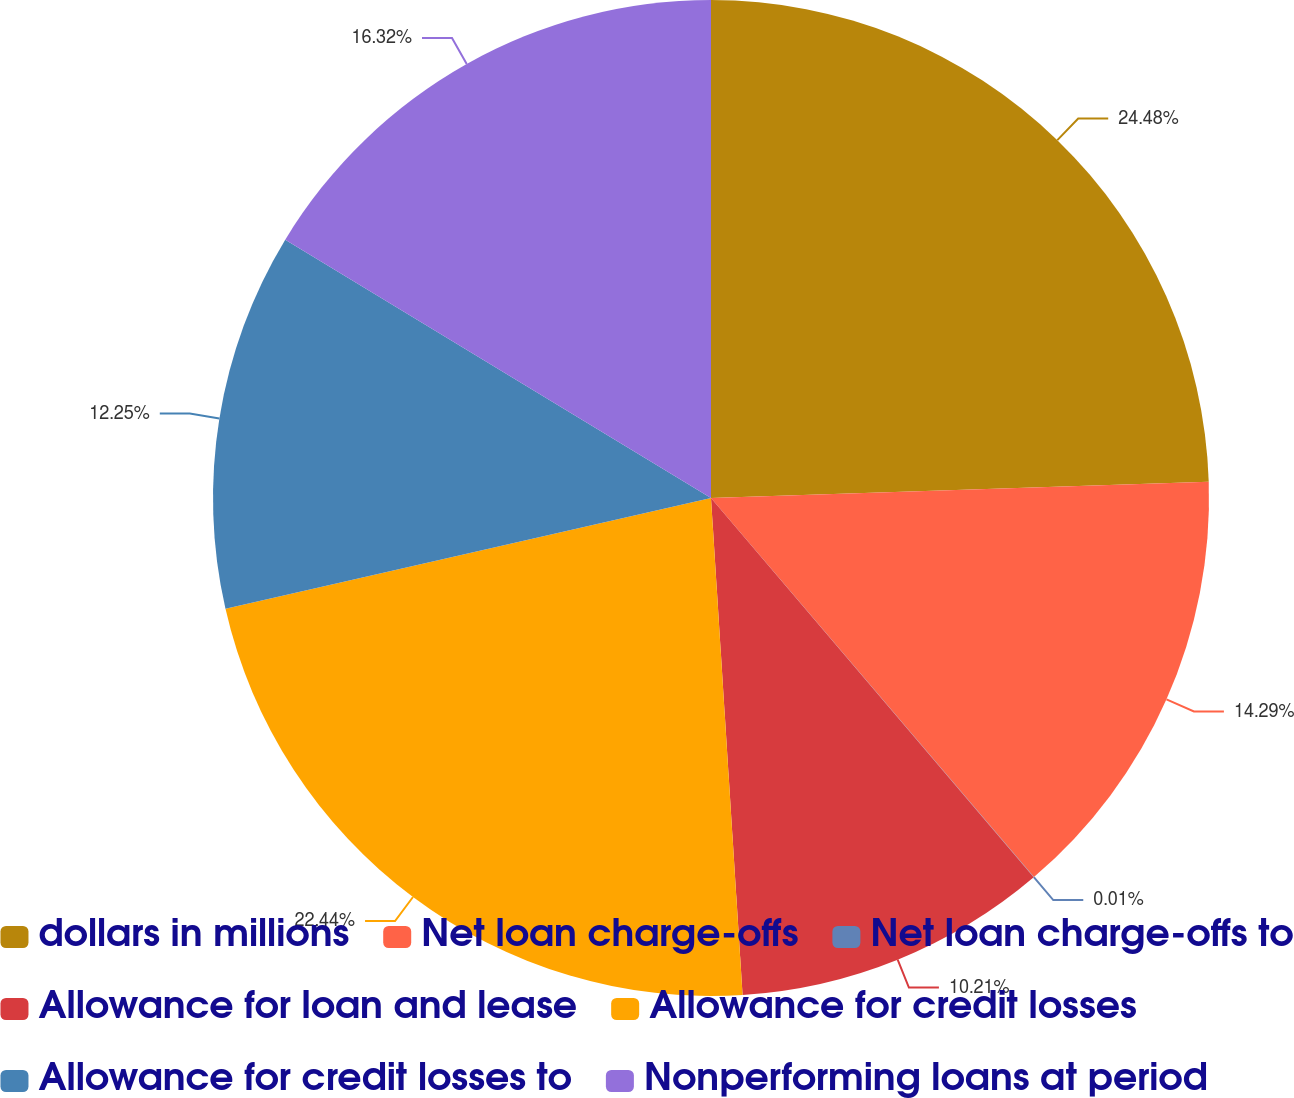Convert chart to OTSL. <chart><loc_0><loc_0><loc_500><loc_500><pie_chart><fcel>dollars in millions<fcel>Net loan charge-offs<fcel>Net loan charge-offs to<fcel>Allowance for loan and lease<fcel>Allowance for credit losses<fcel>Allowance for credit losses to<fcel>Nonperforming loans at period<nl><fcel>24.48%<fcel>14.29%<fcel>0.01%<fcel>10.21%<fcel>22.44%<fcel>12.25%<fcel>16.32%<nl></chart> 